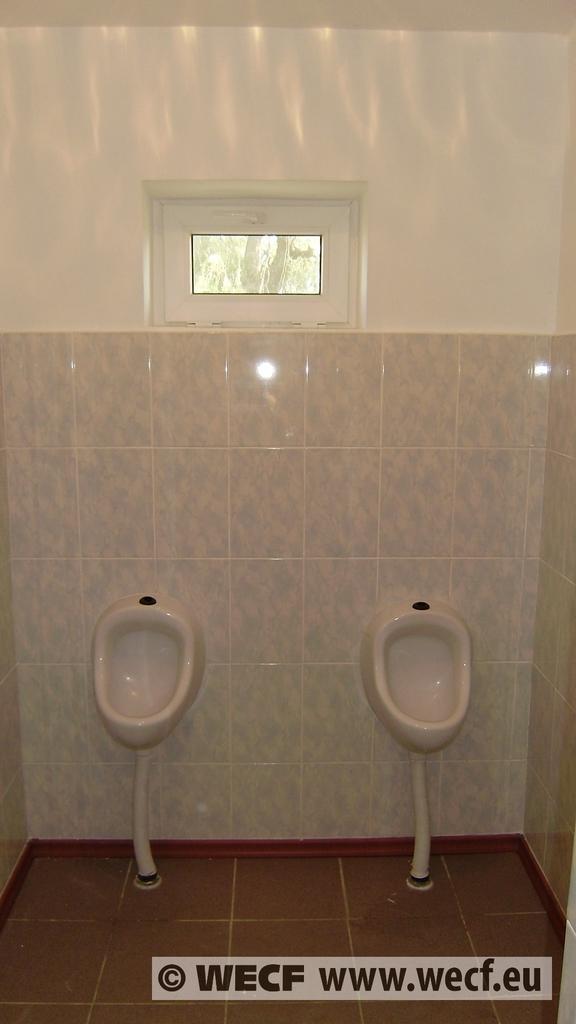Can you describe this image briefly? In this image I can see two toilets and they are in white color. Background the wall is in white color and I can also see a glass door. 